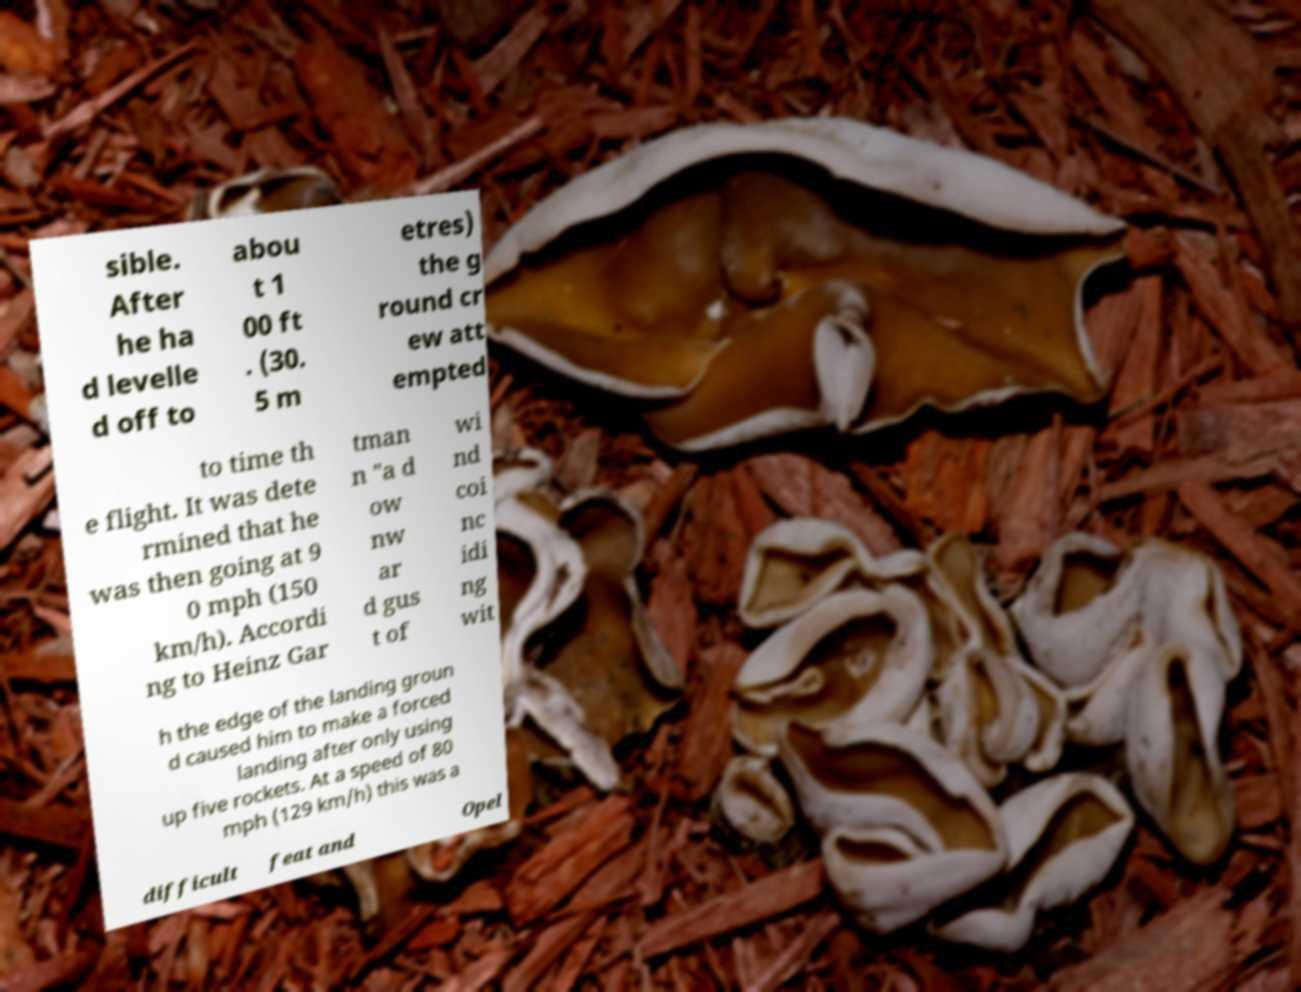I need the written content from this picture converted into text. Can you do that? sible. After he ha d levelle d off to abou t 1 00 ft . (30. 5 m etres) the g round cr ew att empted to time th e flight. It was dete rmined that he was then going at 9 0 mph (150 km/h). Accordi ng to Heinz Gar tman n "a d ow nw ar d gus t of wi nd coi nc idi ng wit h the edge of the landing groun d caused him to make a forced landing after only using up five rockets. At a speed of 80 mph (129 km/h) this was a difficult feat and Opel 